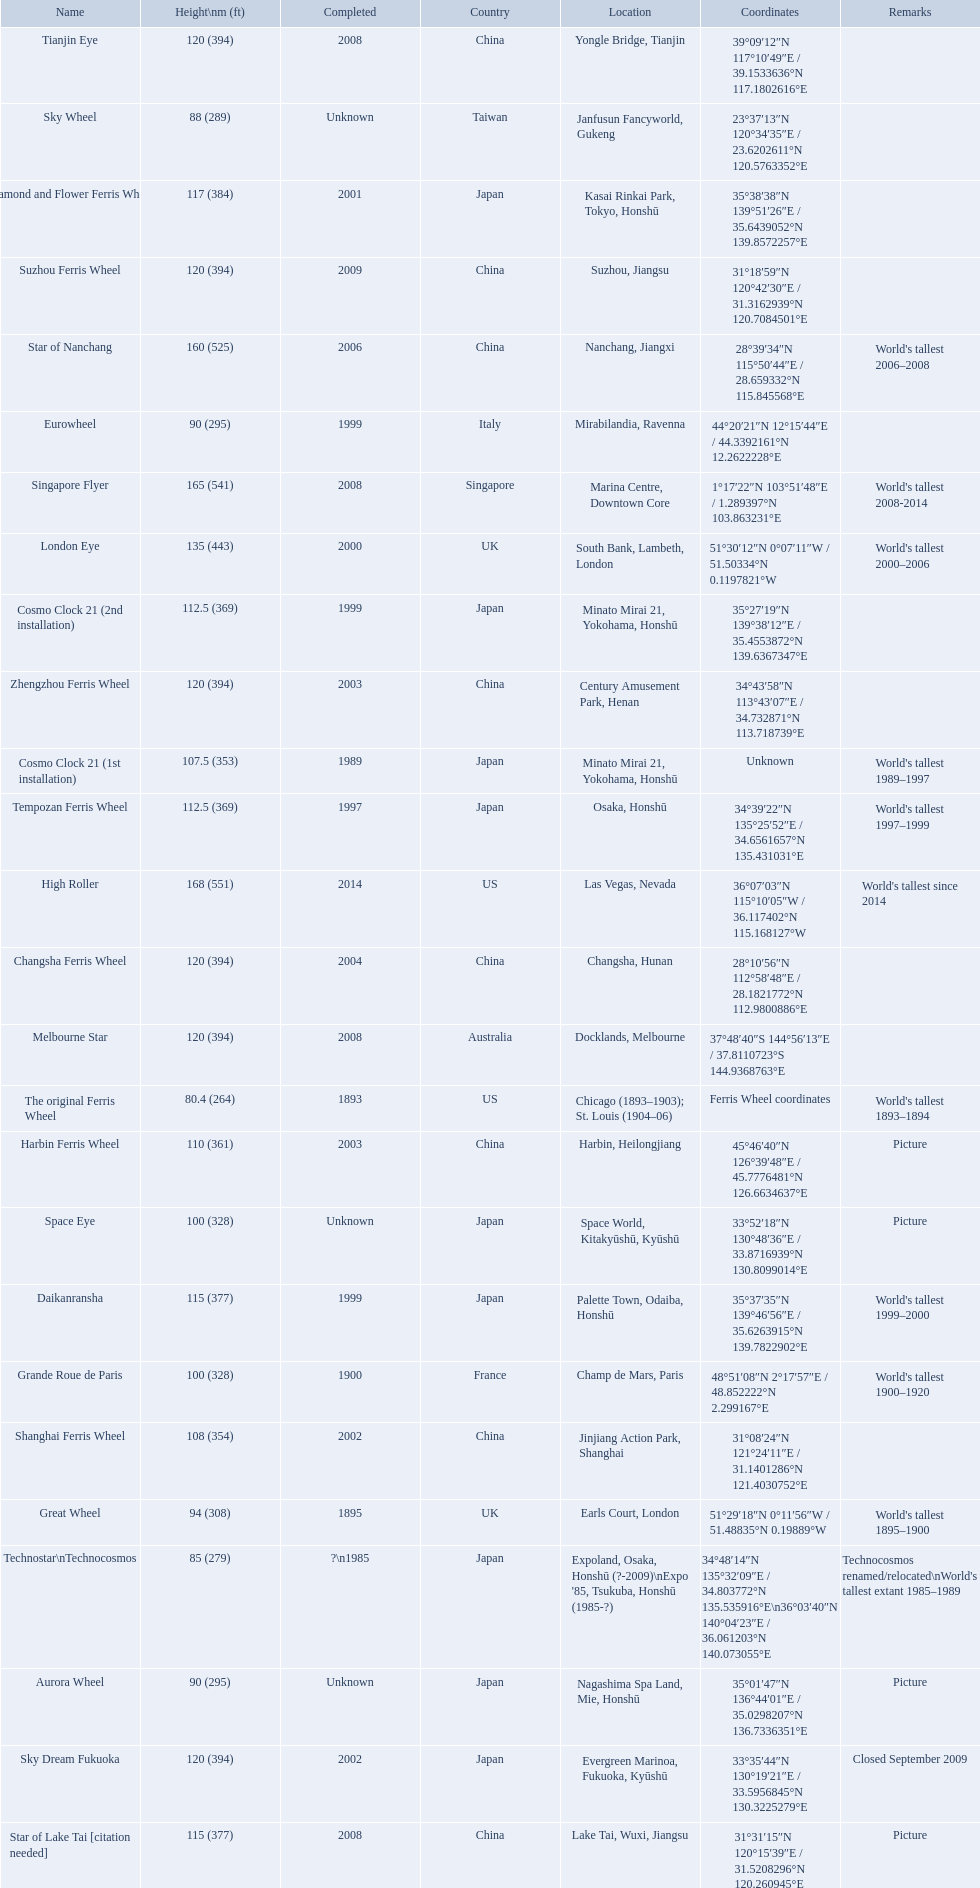What are all of the ferris wheels? High Roller, Singapore Flyer, Star of Nanchang, London Eye, Suzhou Ferris Wheel, Melbourne Star, Tianjin Eye, Changsha Ferris Wheel, Zhengzhou Ferris Wheel, Sky Dream Fukuoka, Diamond and Flower Ferris Wheel, Star of Lake Tai [citation needed], Daikanransha, Cosmo Clock 21 (2nd installation), Tempozan Ferris Wheel, Harbin Ferris Wheel, Shanghai Ferris Wheel, Cosmo Clock 21 (1st installation), Space Eye, Grande Roue de Paris, Great Wheel, Aurora Wheel, Eurowheel, Sky Wheel, Technostar\nTechnocosmos, The original Ferris Wheel. And when were they completed? 2014, 2008, 2006, 2000, 2009, 2008, 2008, 2004, 2003, 2002, 2001, 2008, 1999, 1999, 1997, 2003, 2002, 1989, Unknown, 1900, 1895, Unknown, 1999, Unknown, ?\n1985, 1893. And among star of lake tai, star of nanchang, and melbourne star, which ferris wheel is oldest? Star of Nanchang. 